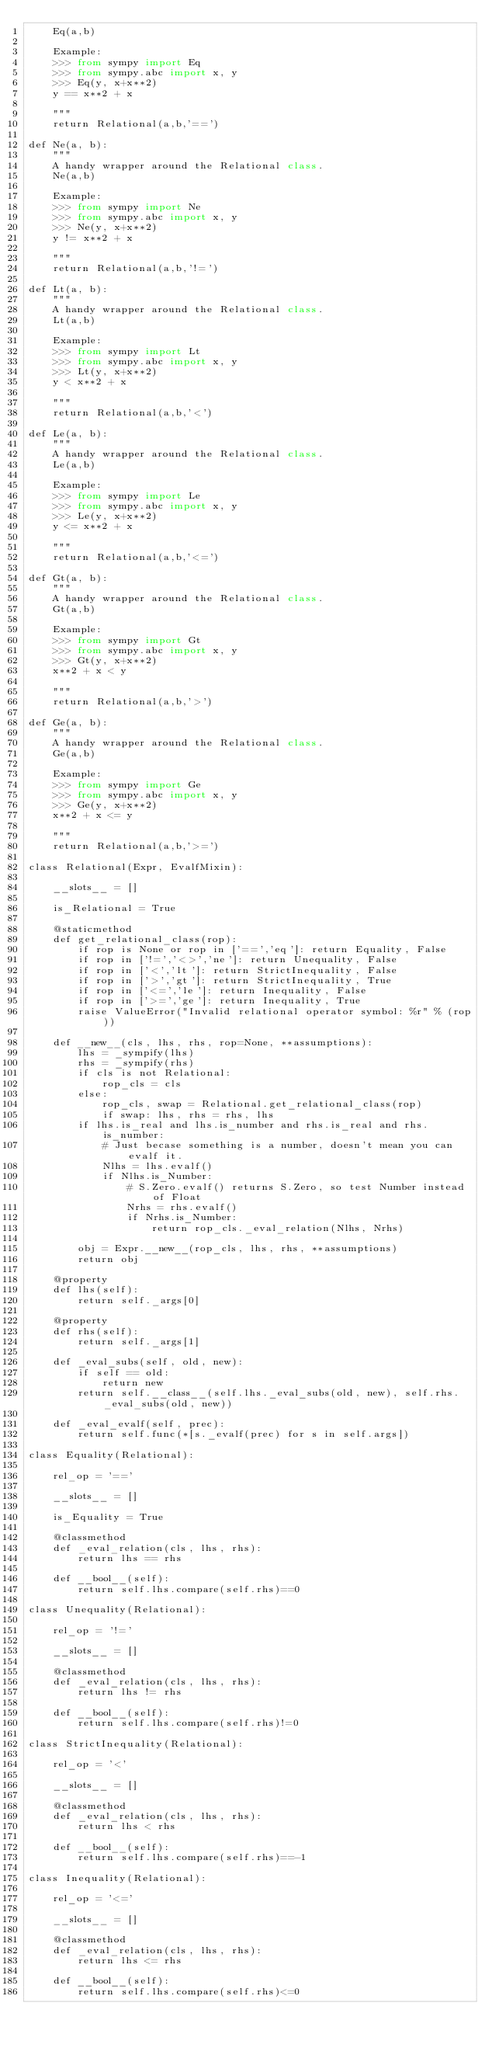<code> <loc_0><loc_0><loc_500><loc_500><_Python_>    Eq(a,b)

    Example:
    >>> from sympy import Eq
    >>> from sympy.abc import x, y
    >>> Eq(y, x+x**2)
    y == x**2 + x

    """
    return Relational(a,b,'==')

def Ne(a, b):
    """
    A handy wrapper around the Relational class.
    Ne(a,b)

    Example:
    >>> from sympy import Ne
    >>> from sympy.abc import x, y
    >>> Ne(y, x+x**2)
    y != x**2 + x

    """
    return Relational(a,b,'!=')

def Lt(a, b):
    """
    A handy wrapper around the Relational class.
    Lt(a,b)

    Example:
    >>> from sympy import Lt
    >>> from sympy.abc import x, y
    >>> Lt(y, x+x**2)
    y < x**2 + x

    """
    return Relational(a,b,'<')

def Le(a, b):
    """
    A handy wrapper around the Relational class.
    Le(a,b)

    Example:
    >>> from sympy import Le
    >>> from sympy.abc import x, y
    >>> Le(y, x+x**2)
    y <= x**2 + x

    """
    return Relational(a,b,'<=')

def Gt(a, b):
    """
    A handy wrapper around the Relational class.
    Gt(a,b)

    Example:
    >>> from sympy import Gt
    >>> from sympy.abc import x, y
    >>> Gt(y, x+x**2)
    x**2 + x < y

    """
    return Relational(a,b,'>')

def Ge(a, b):
    """
    A handy wrapper around the Relational class.
    Ge(a,b)

    Example:
    >>> from sympy import Ge
    >>> from sympy.abc import x, y
    >>> Ge(y, x+x**2)
    x**2 + x <= y

    """
    return Relational(a,b,'>=')

class Relational(Expr, EvalfMixin):

    __slots__ = []

    is_Relational = True

    @staticmethod
    def get_relational_class(rop):
        if rop is None or rop in ['==','eq']: return Equality, False
        if rop in ['!=','<>','ne']: return Unequality, False
        if rop in ['<','lt']: return StrictInequality, False
        if rop in ['>','gt']: return StrictInequality, True
        if rop in ['<=','le']: return Inequality, False
        if rop in ['>=','ge']: return Inequality, True
        raise ValueError("Invalid relational operator symbol: %r" % (rop))

    def __new__(cls, lhs, rhs, rop=None, **assumptions):
        lhs = _sympify(lhs)
        rhs = _sympify(rhs)
        if cls is not Relational:
            rop_cls = cls
        else:
            rop_cls, swap = Relational.get_relational_class(rop)
            if swap: lhs, rhs = rhs, lhs
        if lhs.is_real and lhs.is_number and rhs.is_real and rhs.is_number:
            # Just becase something is a number, doesn't mean you can evalf it.
            Nlhs = lhs.evalf()
            if Nlhs.is_Number:
                # S.Zero.evalf() returns S.Zero, so test Number instead of Float
                Nrhs = rhs.evalf()
                if Nrhs.is_Number:
                    return rop_cls._eval_relation(Nlhs, Nrhs)

        obj = Expr.__new__(rop_cls, lhs, rhs, **assumptions)
        return obj

    @property
    def lhs(self):
        return self._args[0]

    @property
    def rhs(self):
        return self._args[1]

    def _eval_subs(self, old, new):
        if self == old:
            return new
        return self.__class__(self.lhs._eval_subs(old, new), self.rhs._eval_subs(old, new))

    def _eval_evalf(self, prec):
        return self.func(*[s._evalf(prec) for s in self.args])

class Equality(Relational):

    rel_op = '=='

    __slots__ = []

    is_Equality = True

    @classmethod
    def _eval_relation(cls, lhs, rhs):
        return lhs == rhs

    def __bool__(self):
        return self.lhs.compare(self.rhs)==0

class Unequality(Relational):

    rel_op = '!='

    __slots__ = []

    @classmethod
    def _eval_relation(cls, lhs, rhs):
        return lhs != rhs

    def __bool__(self):
        return self.lhs.compare(self.rhs)!=0

class StrictInequality(Relational):

    rel_op = '<'

    __slots__ = []

    @classmethod
    def _eval_relation(cls, lhs, rhs):
        return lhs < rhs

    def __bool__(self):
        return self.lhs.compare(self.rhs)==-1

class Inequality(Relational):

    rel_op = '<='

    __slots__ = []

    @classmethod
    def _eval_relation(cls, lhs, rhs):
        return lhs <= rhs

    def __bool__(self):
        return self.lhs.compare(self.rhs)<=0
</code> 